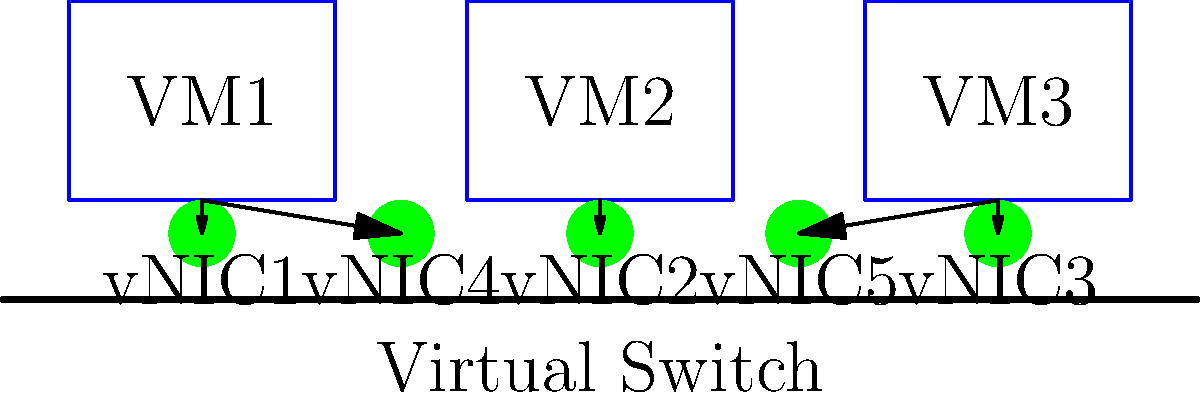In the given virtualized environment topology, which configuration best describes the vNIC placement for VM2? To determine the vNIC placement for VM2, let's analyze the topology step-by-step:

1. We can see three VMs (VM1, VM2, and VM3) connected to a virtual switch.
2. Each VM has at least one vNIC directly beneath it, connected with a straight arrow.
3. Some VMs have additional vNICs connected with angled arrows.

Looking specifically at VM2:
4. VM2 is located in the center of the diagram.
5. It has one vNIC (vNIC2) directly beneath it, connected with a straight arrow.
6. Unlike VM1 and VM3, VM2 does not have any additional vNICs connected with angled arrows.

Therefore, the configuration that best describes the vNIC placement for VM2 is that it has a single vNIC (vNIC2) attached to it.
Answer: Single vNIC (vNIC2) 